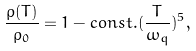Convert formula to latex. <formula><loc_0><loc_0><loc_500><loc_500>\frac { \rho ( T ) } { \rho _ { 0 } } = 1 - c o n s t . ( \frac { T } { \omega _ { q } } ) ^ { 5 } ,</formula> 